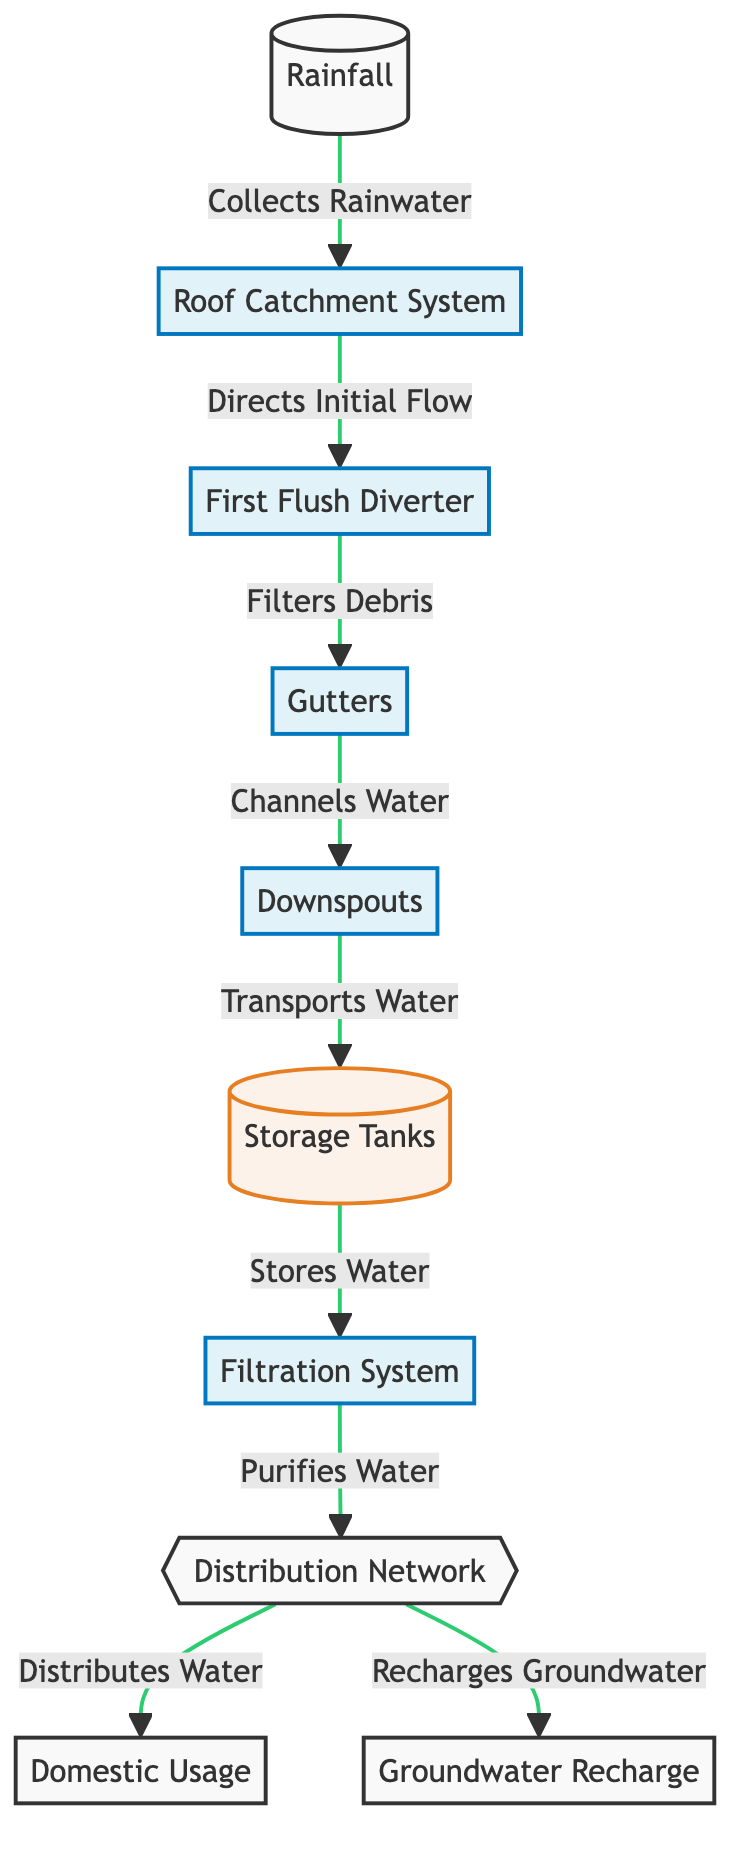What is the first step in the lifecycle of rainwater harvesting? The diagram shows that the first step is "Rainfall," as it collects rainwater into the system.
Answer: Rainfall How many storage tanks are indicated in the diagram? The diagram only shows one node for "Storage Tanks," which implies there is one storage tank in the lifecycle process.
Answer: One What does the "First Flush Diverter" do? According to the diagram, the "First Flush Diverter" directs the initial flow to prevent contaminants from entering the storage tanks.
Answer: Directs initial flow What is the next step after water is collected by the roof catchment system? After collection by the roof catchment system, the next step is the "First Flush Diverter," which filters out debris before the water moves further.
Answer: First Flush Diverter How many outputs does the "Distribution Network" provide according to the diagram? The "Distribution Network" has two outputs as indicated in the diagram: one leading to "Domestic Usage" and another to "Groundwater Recharge."
Answer: Two What does the filtration system do in the lifecycle? The filtration system purifies the water before it is distributed, ensuring the collected rainwater is clean for usage.
Answer: Purifies water Which node is responsible for groundwater recharge? "Groundwater Recharge" is directly linked to the "Distribution Network," indicating its role in replenishing groundwater supplies.
Answer: Groundwater Recharge What is the role of gutters in the lifecycle? Gutters channel the water collected from the roof to downspouts, which transport water towards the storage tanks.
Answer: Channels water What process comes after water is transported to storage tanks? After water is transported to storage tanks, the process that follows is the "Filtration System," where the water gets purified.
Answer: Filtration System 